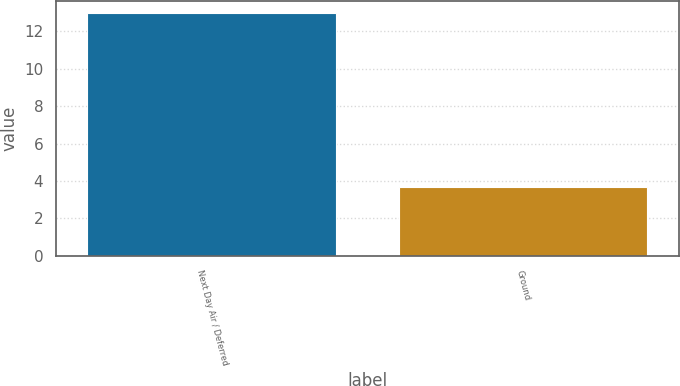Convert chart to OTSL. <chart><loc_0><loc_0><loc_500><loc_500><bar_chart><fcel>Next Day Air / Deferred<fcel>Ground<nl><fcel>13<fcel>3.7<nl></chart> 